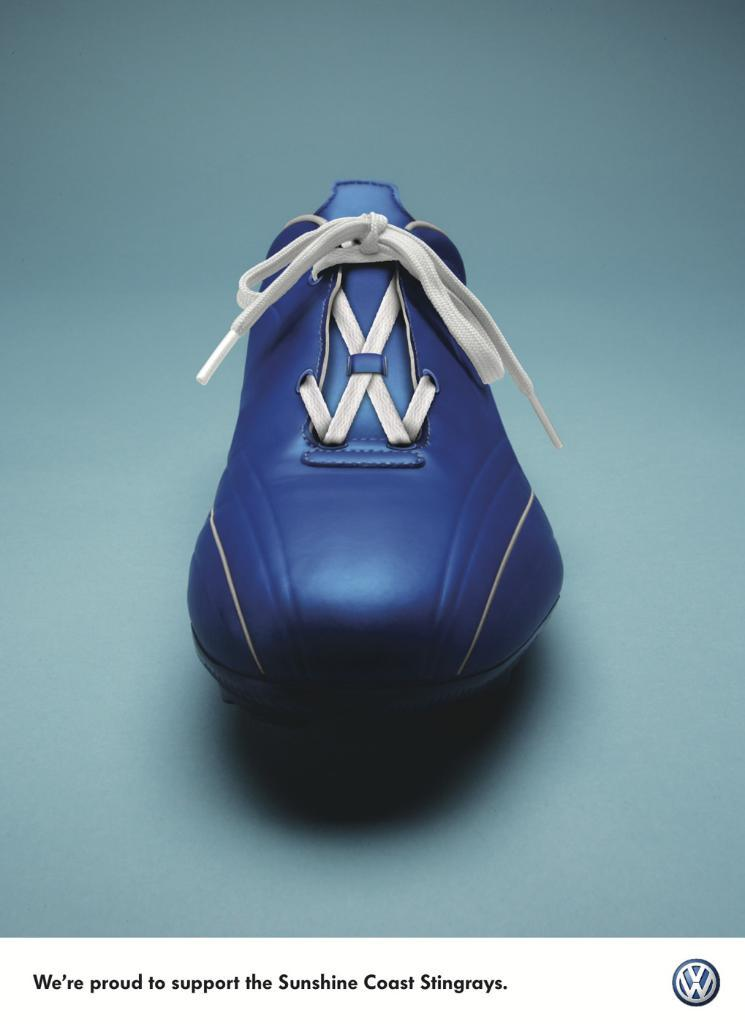<image>
Offer a succinct explanation of the picture presented. Blue shoe with the saying "We're proud to support the Sunshine Coast Stingrays". 